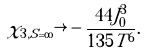Convert formula to latex. <formula><loc_0><loc_0><loc_500><loc_500>\chi _ { 3 , S = \infty } \rightarrow - \frac { 4 4 J _ { 0 } ^ { 3 } } { 1 3 5 T ^ { 6 } } .</formula> 